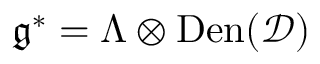<formula> <loc_0><loc_0><loc_500><loc_500>\mathfrak { g } ^ { * } = \Lambda \otimes D e n ( \mathcal { D } )</formula> 